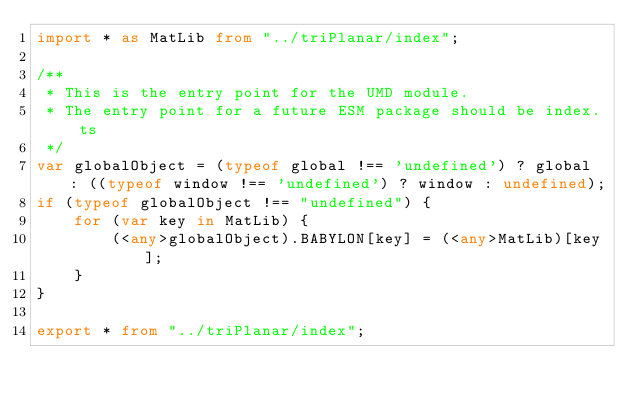Convert code to text. <code><loc_0><loc_0><loc_500><loc_500><_TypeScript_>import * as MatLib from "../triPlanar/index";

/**
 * This is the entry point for the UMD module.
 * The entry point for a future ESM package should be index.ts
 */
var globalObject = (typeof global !== 'undefined') ? global : ((typeof window !== 'undefined') ? window : undefined);
if (typeof globalObject !== "undefined") {
    for (var key in MatLib) {
        (<any>globalObject).BABYLON[key] = (<any>MatLib)[key];
    }
}

export * from "../triPlanar/index";</code> 